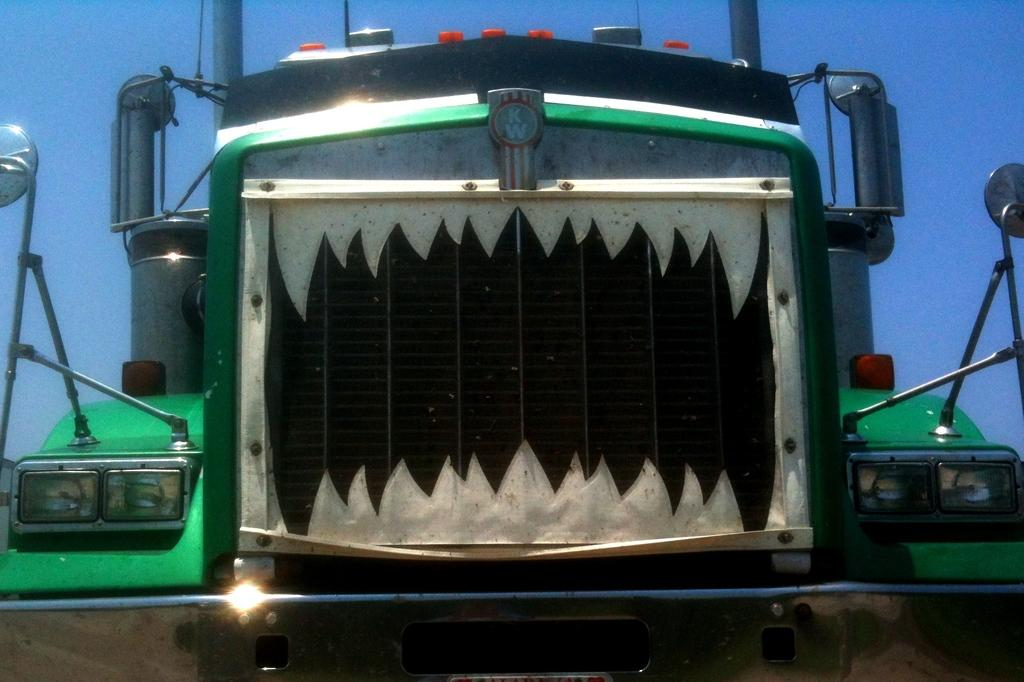What is the main subject in the center of the image? There is a vehicle in the center of the image. What can be seen at the top of the image? The sky is visible at the top of the image. What type of beast is providing support for the vehicle in the image? There is no beast present in the image, and the vehicle is not being supported by any creature. 